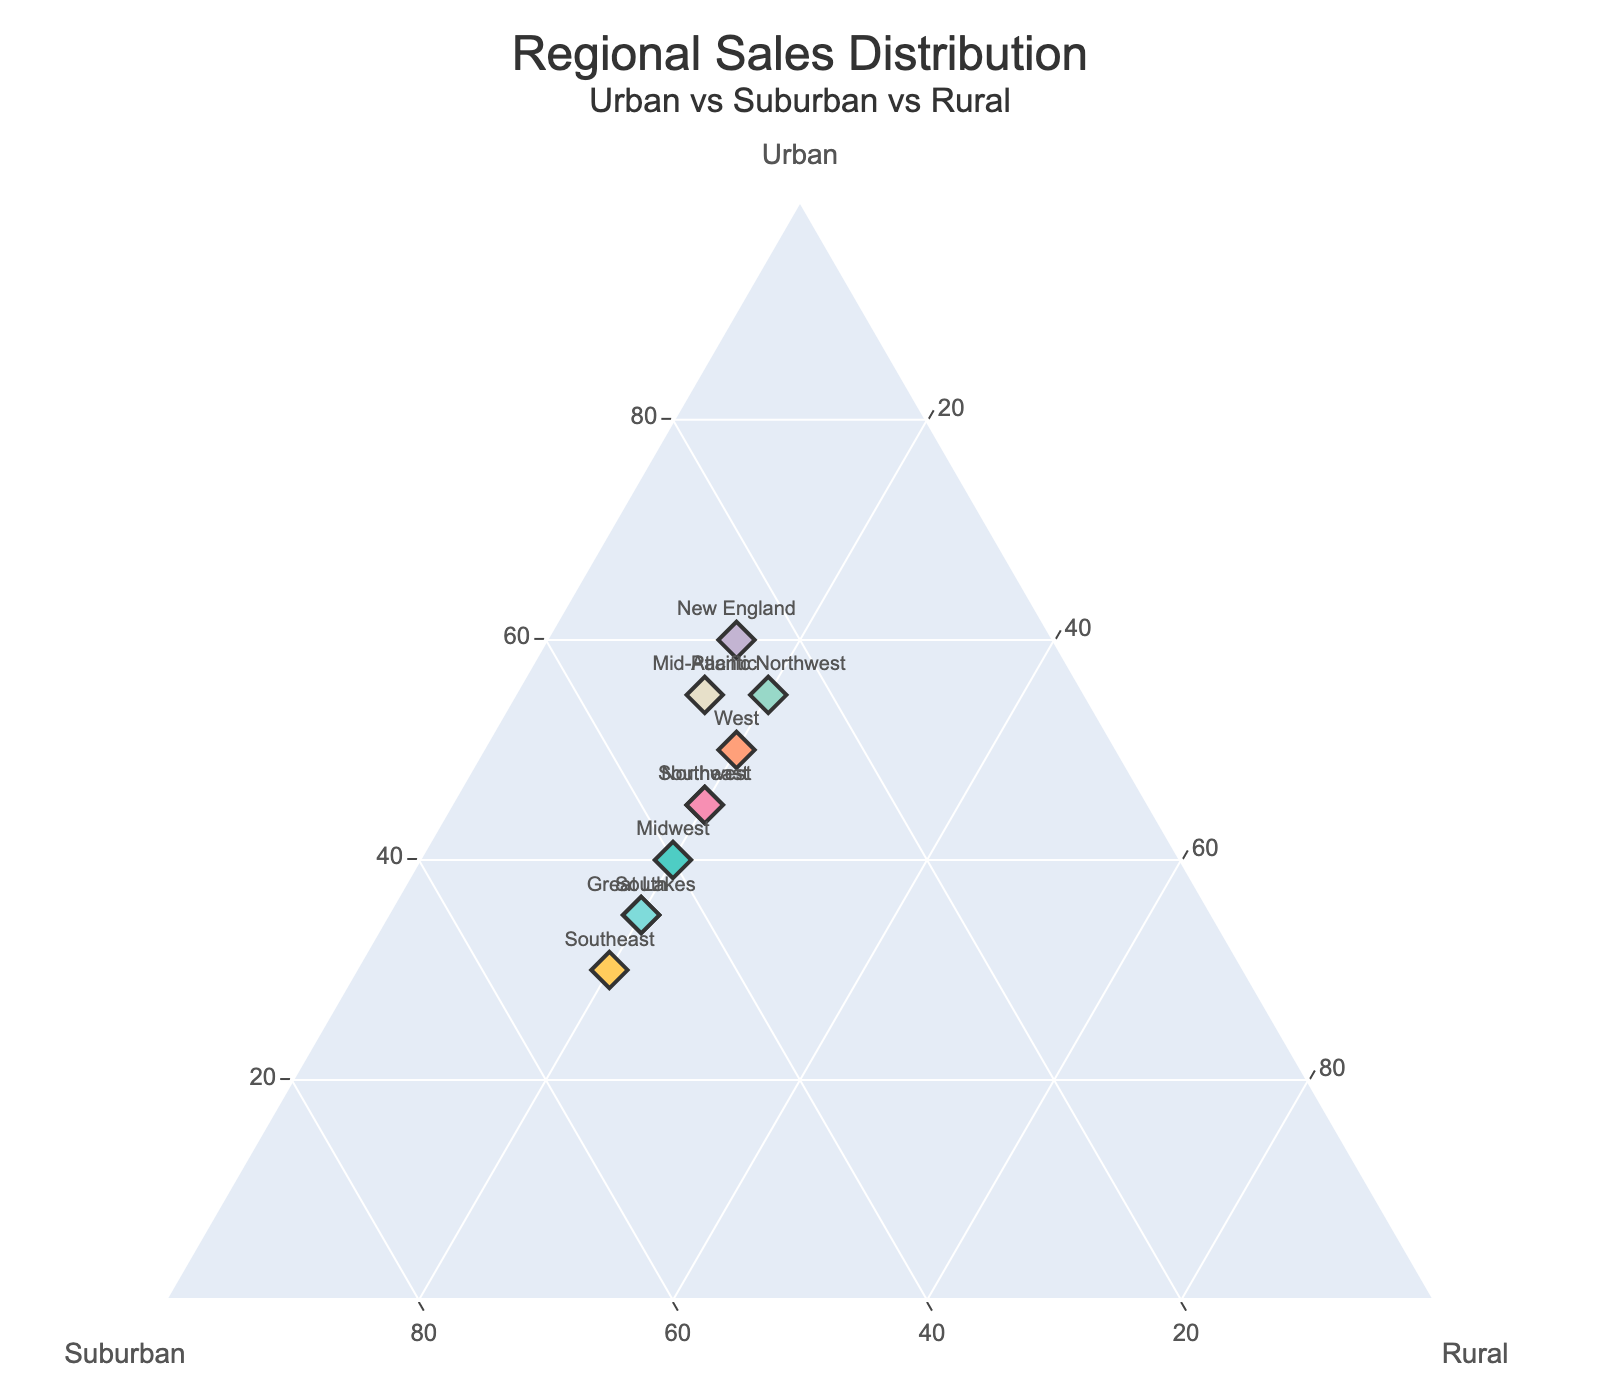How many regions have been plotted in the ternary plot? Count the total number of data points represented by markers. Each marker represents one region.
Answer: 10 What is the highest percentage of Urban sales and which region does it belong to? Refer to the markers on the plot to find the one located furthest towards the Urban axis. The region label next to this marker represents the region with the highest Urban sales.
Answer: New England, 60% Which region has an equal distribution between Urban and Suburban sales? Look for the data points where the Urban and Suburban components are the same. This pattern is necessary for equal distribution.
Answer: Midwest, 40% each Which regions have the same Rural sales percentage? Identify data points located on the same horizontal level relative to the Rural axis. Cross-check their labels to ensure they all have the same Rural percentage.
Answer: Multiple regions (Northeast, Midwest, South, West, Pacific Northwest, Southwest, Southeast, Great Lakes) have 20% Rural sales, New England and Mid-Atlantic have 15% Rural sales How does the Suburban sales percentage of Southeast compare to that of Northeast? Cross-reference the markers for both Southeast and Northeast and compare their positions along the Suburban axis.
Answer: Southeast: 50%, Northeast: 35% Which region has the lowest Rural sales percentage and how does it compare to the Rural sales percentage of Mid-Atlantic? Locate the marker with the lowest position on the Rural axis. Note this percentage and directly compare it with the Rural sales percentage of the Mid-Atlantic region, which is provided in the data table.
Answer: New England, both have 15% Are there any regions with greater than 50% Urban sales? If yes, list them. Examine the Urban axis, identify markers beyond the 50% mark, and note the corresponding region labels.
Answer: Pacific Northwest, New England, Mid-Atlantic What is the average Suburban sales percentage for the South and Southeast regions? Sum up the Suburban sales percentages for the South (45%) and Southeast (50%), and then divide by the number of regions (2).
Answer: (45+50)/2 = 47.5% Which regions lie closest to the Rural axis and what does this indicate about their Rural sales distribution? Identify the data points nearest to the Rural axis. The closer to the axis, the higher the percentage of Rural sales.
Answer: New England and Mid-Atlantic, both have 15% What is the difference in Urban sales percentage between the West and Great Lakes regions? Locate the markers for West (50%) and Great Lakes (35%) and subtract the smaller value from the larger value.
Answer: 50% - 35% = 15% 